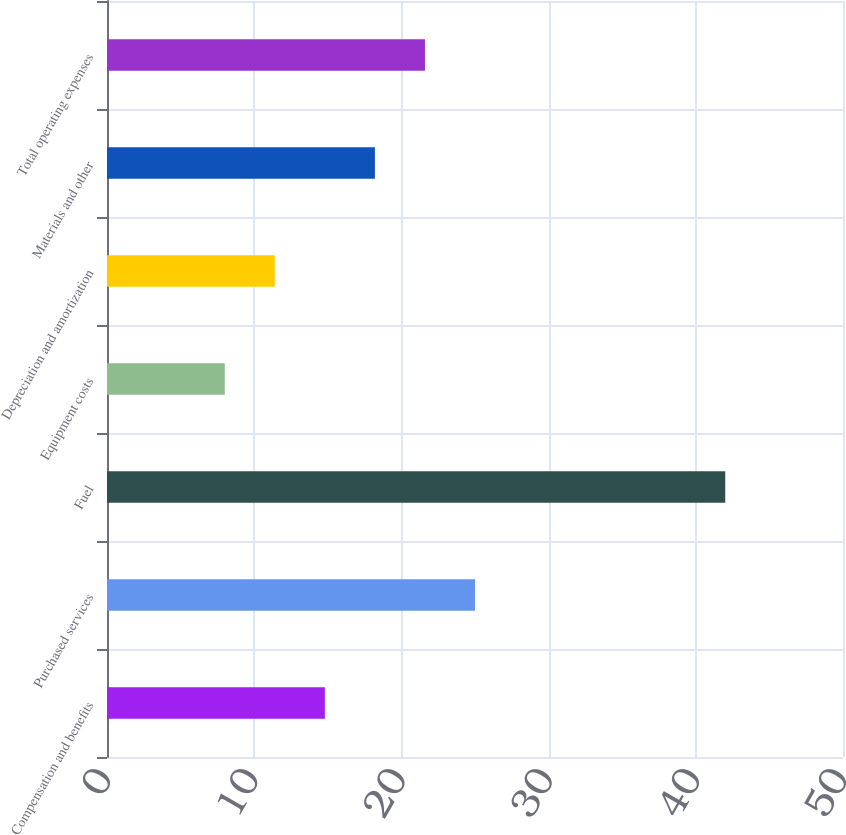<chart> <loc_0><loc_0><loc_500><loc_500><bar_chart><fcel>Compensation and benefits<fcel>Purchased services<fcel>Fuel<fcel>Equipment costs<fcel>Depreciation and amortization<fcel>Materials and other<fcel>Total operating expenses<nl><fcel>14.8<fcel>25<fcel>42<fcel>8<fcel>11.4<fcel>18.2<fcel>21.6<nl></chart> 